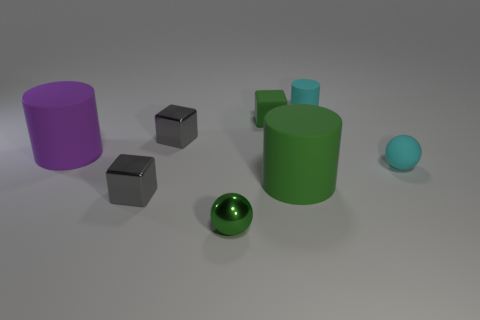Add 1 tiny gray metallic objects. How many objects exist? 9 Subtract all spheres. How many objects are left? 6 Add 4 tiny metal cubes. How many tiny metal cubes are left? 6 Add 3 red shiny objects. How many red shiny objects exist? 3 Subtract 0 red spheres. How many objects are left? 8 Subtract all cyan things. Subtract all green shiny objects. How many objects are left? 5 